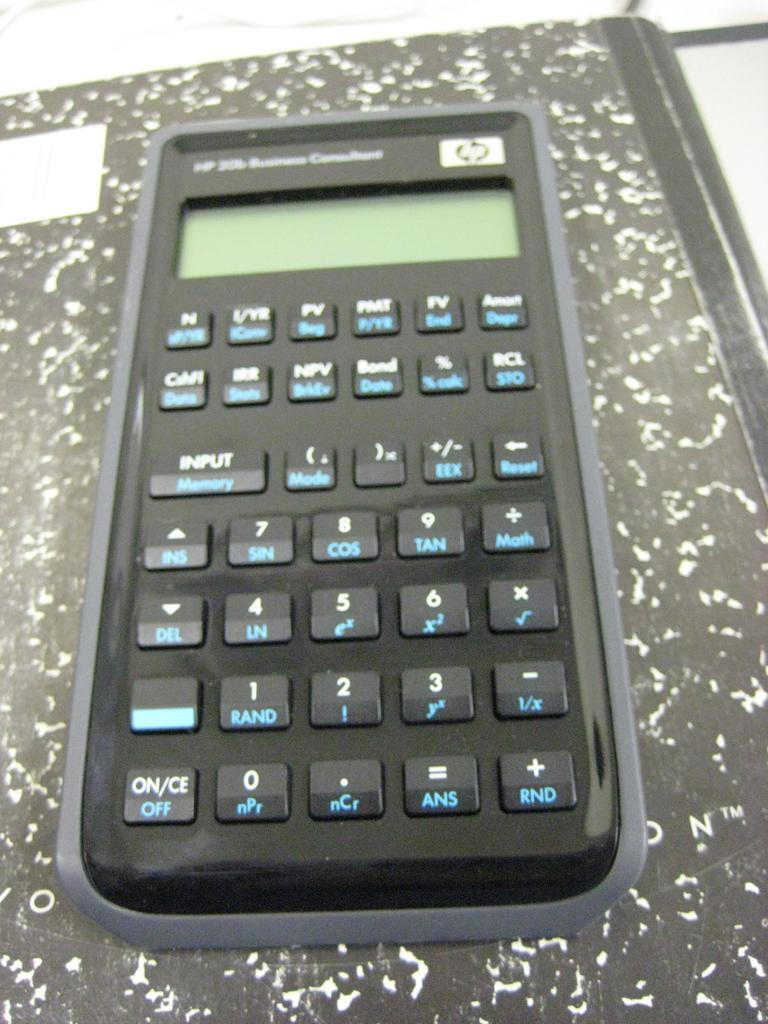Provide a one-sentence caption for the provided image. A calculator has white ON text and blue OFF text. 